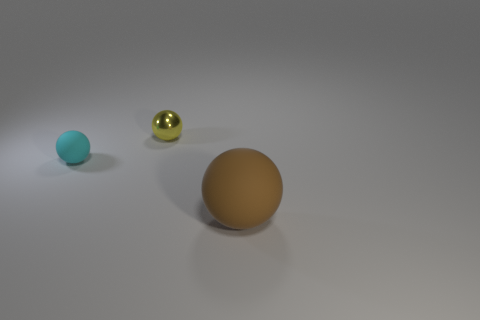Is the material of the yellow ball the same as the big ball?
Give a very brief answer. No. How many cubes are either cyan metallic things or big brown rubber objects?
Keep it short and to the point. 0. How big is the matte object that is on the left side of the rubber ball right of the object on the left side of the yellow shiny sphere?
Ensure brevity in your answer.  Small. There is a yellow thing that is the same shape as the brown object; what is its size?
Your answer should be compact. Small. What number of small balls are left of the large object?
Your answer should be compact. 2. Does the rubber ball behind the brown matte ball have the same color as the tiny shiny thing?
Offer a terse response. No. What number of cyan objects are tiny rubber objects or big spheres?
Your answer should be compact. 1. What is the color of the object that is right of the shiny object right of the cyan sphere?
Offer a terse response. Brown. There is a rubber thing on the right side of the tiny yellow shiny object; what color is it?
Make the answer very short. Brown. There is a matte thing to the right of the cyan matte thing; is its size the same as the metal sphere?
Your answer should be very brief. No. 